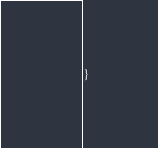<code> <loc_0><loc_0><loc_500><loc_500><_C++_>}
</code> 